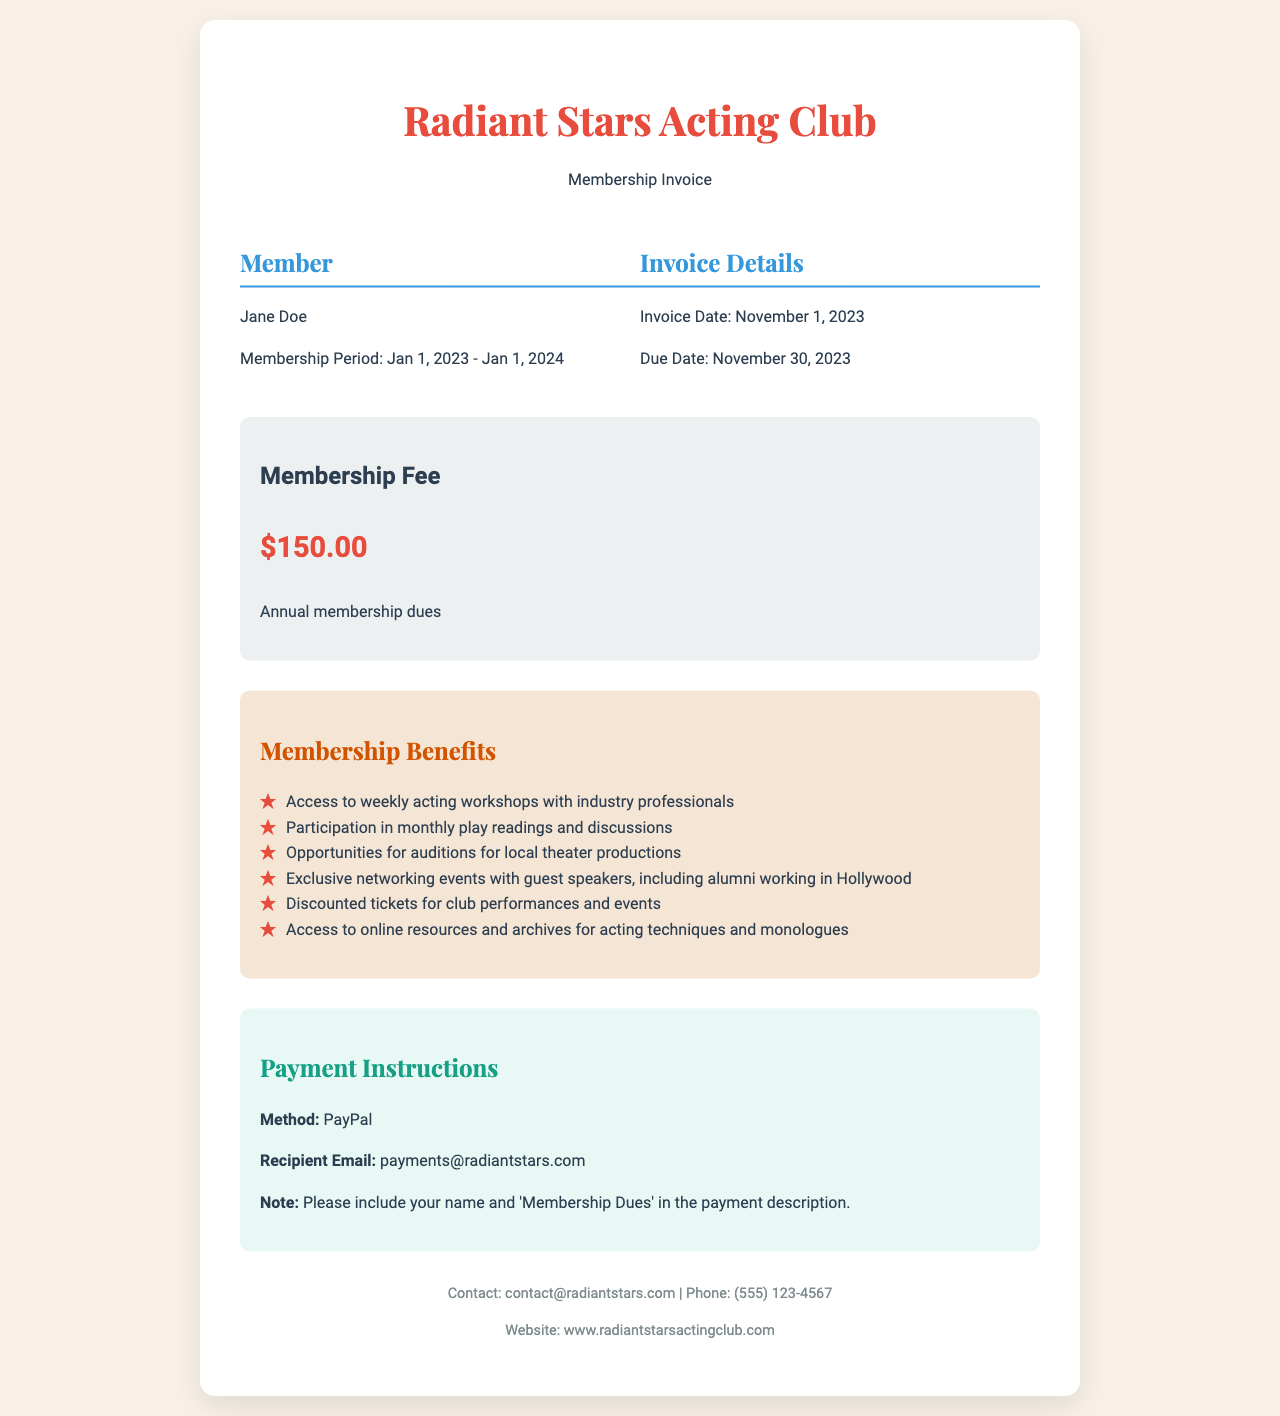What is the name of the acting club? The name of the acting club is stated at the top of the invoice under the header.
Answer: Radiant Stars Acting Club What is the membership fee? The membership fee is listed in the fee section of the invoice.
Answer: $150.00 What is the membership period? The membership period is mentioned in the member information section.
Answer: Jan 1, 2023 - Jan 1, 2024 What is the due date for the invoice? The due date is indicated in the invoice details section.
Answer: November 30, 2023 What are the payment instructions? The payment instructions detail the method and recipient information for the payment.
Answer: PayPal What benefits are included with membership? The benefits are outlined in the benefits section and include several offerings.
Answer: Access to weekly acting workshops with industry professionals Who should the payment be addressed to? The recipient email for payment is specified in the document under payment instructions.
Answer: payments@radiantstars.com What is the invoice date? The invoice date is provided in the invoice details section.
Answer: November 1, 2023 Which type of events does the membership offer access to? The types of events available through the membership are detailed in the benefits section.
Answer: Exclusive networking events with guest speakers, including alumni working in Hollywood 